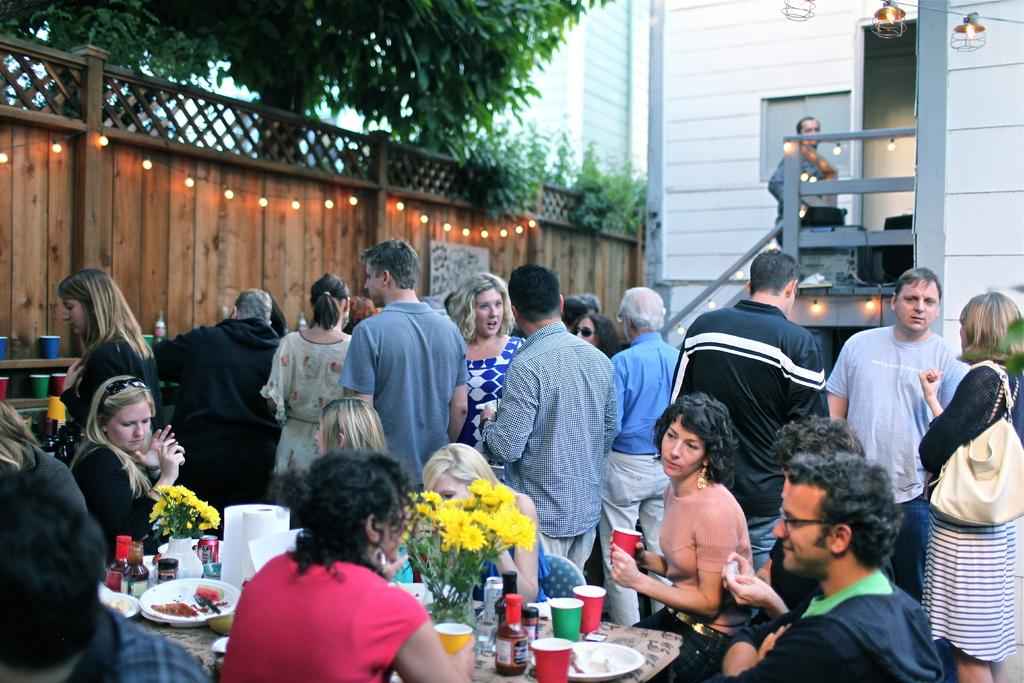What type of gathering is depicted in the image? There are people at a party in the image. How are some of the people positioned at the party? Some people are sitting around a table, while others are standing. What type of corn is being served at the party? There is no corn present in the image; it is a party with people sitting and standing. 